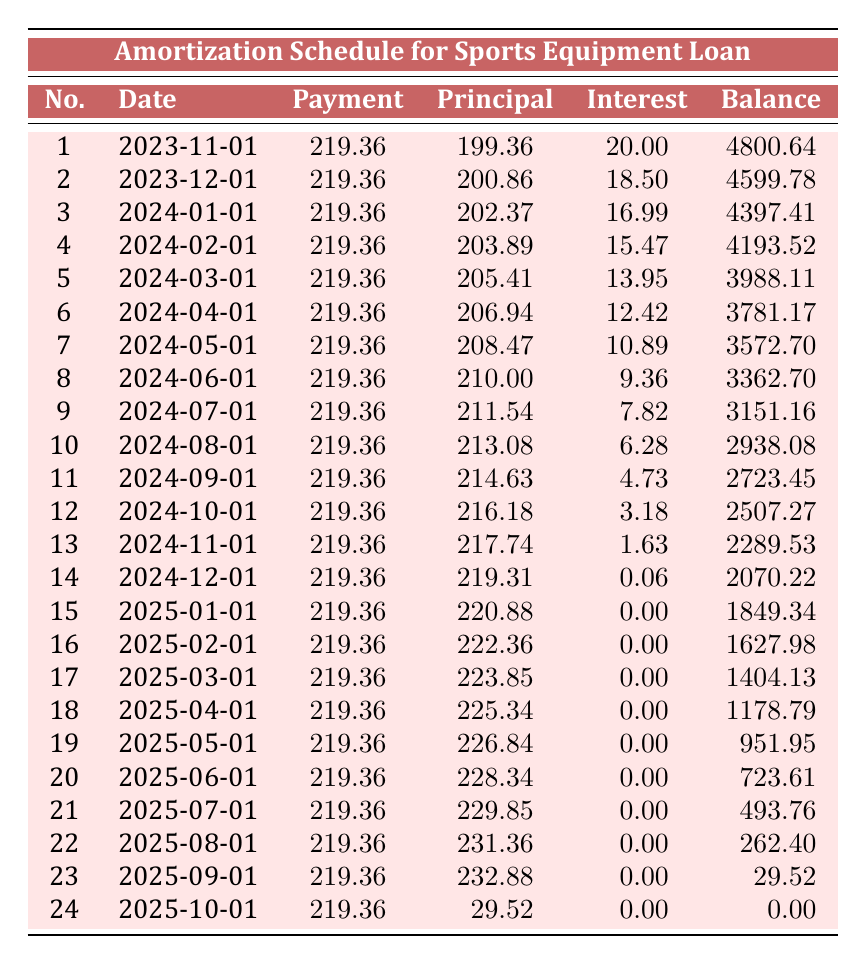What is the total loan amount? The total loan amount is specified in the loan details section of the table, which shows a loan amount of 5000.
Answer: 5000 How much is the monthly payment? The monthly payment is also included in the loan details, showing that the monthly payment is 219.36.
Answer: 219.36 What is the remaining balance after the first payment? Looking at the first payment row, the remaining balance after the payment made on 2023-11-01 is 4800.64.
Answer: 4800.64 During which month does the principal payment exceed 220? By reviewing the principal payment column, I can see that in the payment number 15 (2025-01-01), the principal payment is 220.88, which exceeds 220.
Answer: January 2025 What is the total amount paid in interest over the loan term? To find the total interest paid, I sum up all the interest payments from each payment row: (20.00 + 18.50 + 16.99 + 15.47 + 13.95 + 12.42 + 10.89 + 9.36 + 7.82 + 6.28 + 4.73 + 3.18 + 1.63 + 0.06 + 0.00 + 0.00 + 0.00 + 0.00 + 0.00 + 0.00 + 0.00 + 0.00 + 0.00 + 0.00) = 105.70.
Answer: 105.70 Do any payments have a zero interest amount? I can observe rows for payments 15 through 23, where the interest payment is 0.00, confirming that those payments had no interest.
Answer: Yes What is the average principal payment for the first 6 months? I find the principal payments for the first 6 months: (199.36 + 200.86 + 202.37 + 203.89 + 205.41 + 206.94) = 1218.83. Dividing this sum by 6 gives me an average principal payment of 203.14.
Answer: 203.14 How much did the remaining balance decrease from the first to the last payment? The remaining balance after the first payment is 4800.64, and after the last payment, it is 0.00. The decrease in the remaining balance is 4800.64 - 0.00 = 4800.64.
Answer: 4800.64 In which month does the payment become almost entirely principal? By examining the principal payment values towards the end of the payment schedule, I can see that in the last few payments, specifically from payment number 15 and onward, the principal payments are significantly high, with the last payment showing 29.52 in principal payment. This suggests the structure is heavily skewed towards principal repayment.
Answer: After January 2025 